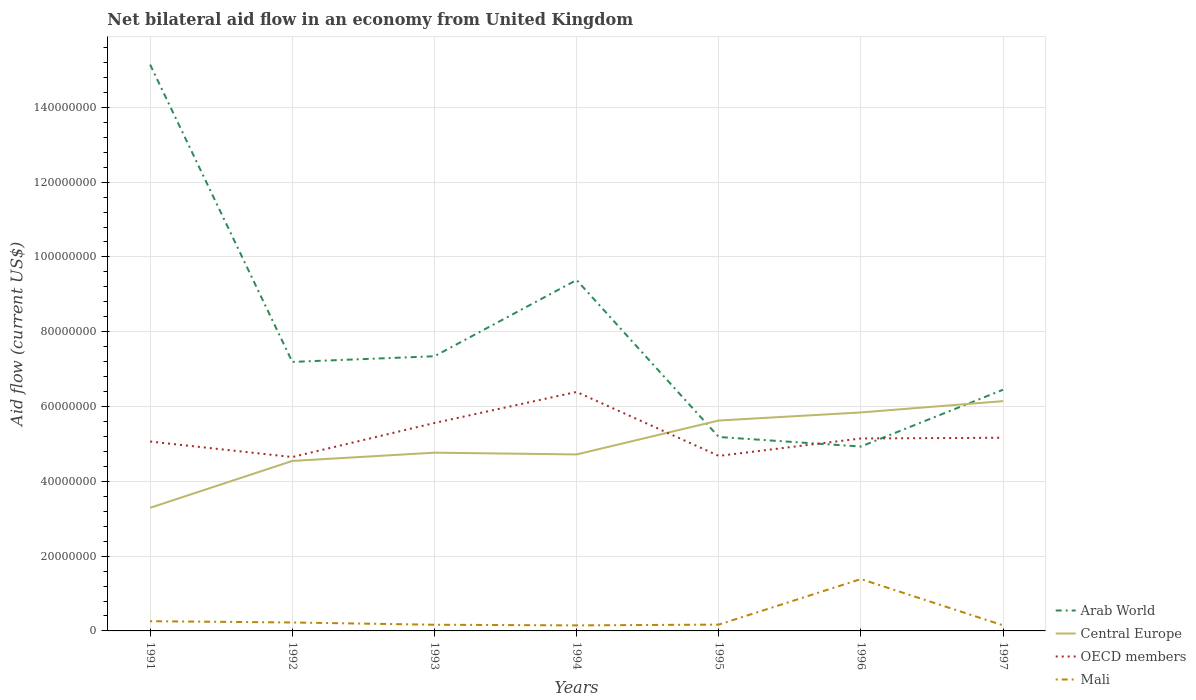Does the line corresponding to Arab World intersect with the line corresponding to OECD members?
Your answer should be very brief. Yes. Is the number of lines equal to the number of legend labels?
Ensure brevity in your answer.  Yes. Across all years, what is the maximum net bilateral aid flow in Arab World?
Your response must be concise. 4.93e+07. In which year was the net bilateral aid flow in Arab World maximum?
Provide a succinct answer. 1996. What is the total net bilateral aid flow in Central Europe in the graph?
Provide a short and direct response. -1.12e+07. What is the difference between the highest and the second highest net bilateral aid flow in Mali?
Your answer should be compact. 1.24e+07. What is the difference between the highest and the lowest net bilateral aid flow in OECD members?
Offer a very short reply. 2. Is the net bilateral aid flow in Mali strictly greater than the net bilateral aid flow in Arab World over the years?
Offer a very short reply. Yes. How many lines are there?
Your response must be concise. 4. How many years are there in the graph?
Give a very brief answer. 7. Where does the legend appear in the graph?
Provide a succinct answer. Bottom right. How many legend labels are there?
Your response must be concise. 4. How are the legend labels stacked?
Your response must be concise. Vertical. What is the title of the graph?
Keep it short and to the point. Net bilateral aid flow in an economy from United Kingdom. Does "Nigeria" appear as one of the legend labels in the graph?
Your answer should be very brief. No. What is the label or title of the X-axis?
Your answer should be compact. Years. What is the label or title of the Y-axis?
Provide a short and direct response. Aid flow (current US$). What is the Aid flow (current US$) of Arab World in 1991?
Offer a terse response. 1.51e+08. What is the Aid flow (current US$) in Central Europe in 1991?
Keep it short and to the point. 3.29e+07. What is the Aid flow (current US$) of OECD members in 1991?
Offer a very short reply. 5.06e+07. What is the Aid flow (current US$) of Mali in 1991?
Give a very brief answer. 2.60e+06. What is the Aid flow (current US$) of Arab World in 1992?
Keep it short and to the point. 7.19e+07. What is the Aid flow (current US$) in Central Europe in 1992?
Provide a short and direct response. 4.54e+07. What is the Aid flow (current US$) of OECD members in 1992?
Give a very brief answer. 4.65e+07. What is the Aid flow (current US$) of Mali in 1992?
Provide a short and direct response. 2.26e+06. What is the Aid flow (current US$) in Arab World in 1993?
Offer a very short reply. 7.34e+07. What is the Aid flow (current US$) of Central Europe in 1993?
Provide a short and direct response. 4.77e+07. What is the Aid flow (current US$) in OECD members in 1993?
Provide a short and direct response. 5.56e+07. What is the Aid flow (current US$) of Mali in 1993?
Offer a terse response. 1.65e+06. What is the Aid flow (current US$) of Arab World in 1994?
Keep it short and to the point. 9.38e+07. What is the Aid flow (current US$) in Central Europe in 1994?
Ensure brevity in your answer.  4.72e+07. What is the Aid flow (current US$) in OECD members in 1994?
Offer a terse response. 6.39e+07. What is the Aid flow (current US$) of Mali in 1994?
Offer a very short reply. 1.48e+06. What is the Aid flow (current US$) of Arab World in 1995?
Ensure brevity in your answer.  5.18e+07. What is the Aid flow (current US$) in Central Europe in 1995?
Your response must be concise. 5.63e+07. What is the Aid flow (current US$) in OECD members in 1995?
Offer a very short reply. 4.68e+07. What is the Aid flow (current US$) in Mali in 1995?
Your response must be concise. 1.69e+06. What is the Aid flow (current US$) of Arab World in 1996?
Keep it short and to the point. 4.93e+07. What is the Aid flow (current US$) in Central Europe in 1996?
Offer a terse response. 5.84e+07. What is the Aid flow (current US$) in OECD members in 1996?
Ensure brevity in your answer.  5.15e+07. What is the Aid flow (current US$) in Mali in 1996?
Provide a succinct answer. 1.39e+07. What is the Aid flow (current US$) of Arab World in 1997?
Offer a terse response. 6.45e+07. What is the Aid flow (current US$) of Central Europe in 1997?
Offer a very short reply. 6.14e+07. What is the Aid flow (current US$) of OECD members in 1997?
Offer a terse response. 5.16e+07. What is the Aid flow (current US$) of Mali in 1997?
Offer a very short reply. 1.49e+06. Across all years, what is the maximum Aid flow (current US$) of Arab World?
Offer a very short reply. 1.51e+08. Across all years, what is the maximum Aid flow (current US$) of Central Europe?
Your answer should be compact. 6.14e+07. Across all years, what is the maximum Aid flow (current US$) of OECD members?
Offer a terse response. 6.39e+07. Across all years, what is the maximum Aid flow (current US$) of Mali?
Offer a very short reply. 1.39e+07. Across all years, what is the minimum Aid flow (current US$) of Arab World?
Ensure brevity in your answer.  4.93e+07. Across all years, what is the minimum Aid flow (current US$) of Central Europe?
Offer a terse response. 3.29e+07. Across all years, what is the minimum Aid flow (current US$) in OECD members?
Offer a terse response. 4.65e+07. Across all years, what is the minimum Aid flow (current US$) in Mali?
Ensure brevity in your answer.  1.48e+06. What is the total Aid flow (current US$) of Arab World in the graph?
Provide a succinct answer. 5.56e+08. What is the total Aid flow (current US$) in Central Europe in the graph?
Make the answer very short. 3.49e+08. What is the total Aid flow (current US$) in OECD members in the graph?
Make the answer very short. 3.67e+08. What is the total Aid flow (current US$) of Mali in the graph?
Your response must be concise. 2.50e+07. What is the difference between the Aid flow (current US$) of Arab World in 1991 and that in 1992?
Provide a short and direct response. 7.95e+07. What is the difference between the Aid flow (current US$) of Central Europe in 1991 and that in 1992?
Keep it short and to the point. -1.25e+07. What is the difference between the Aid flow (current US$) of OECD members in 1991 and that in 1992?
Your answer should be very brief. 4.15e+06. What is the difference between the Aid flow (current US$) of Mali in 1991 and that in 1992?
Keep it short and to the point. 3.40e+05. What is the difference between the Aid flow (current US$) of Arab World in 1991 and that in 1993?
Your answer should be compact. 7.80e+07. What is the difference between the Aid flow (current US$) of Central Europe in 1991 and that in 1993?
Your answer should be compact. -1.47e+07. What is the difference between the Aid flow (current US$) of OECD members in 1991 and that in 1993?
Your response must be concise. -4.96e+06. What is the difference between the Aid flow (current US$) of Mali in 1991 and that in 1993?
Your response must be concise. 9.50e+05. What is the difference between the Aid flow (current US$) in Arab World in 1991 and that in 1994?
Provide a short and direct response. 5.76e+07. What is the difference between the Aid flow (current US$) in Central Europe in 1991 and that in 1994?
Your response must be concise. -1.43e+07. What is the difference between the Aid flow (current US$) of OECD members in 1991 and that in 1994?
Offer a terse response. -1.33e+07. What is the difference between the Aid flow (current US$) in Mali in 1991 and that in 1994?
Provide a short and direct response. 1.12e+06. What is the difference between the Aid flow (current US$) in Arab World in 1991 and that in 1995?
Make the answer very short. 9.96e+07. What is the difference between the Aid flow (current US$) of Central Europe in 1991 and that in 1995?
Offer a terse response. -2.33e+07. What is the difference between the Aid flow (current US$) of OECD members in 1991 and that in 1995?
Your answer should be very brief. 3.84e+06. What is the difference between the Aid flow (current US$) in Mali in 1991 and that in 1995?
Keep it short and to the point. 9.10e+05. What is the difference between the Aid flow (current US$) of Arab World in 1991 and that in 1996?
Ensure brevity in your answer.  1.02e+08. What is the difference between the Aid flow (current US$) in Central Europe in 1991 and that in 1996?
Give a very brief answer. -2.55e+07. What is the difference between the Aid flow (current US$) in OECD members in 1991 and that in 1996?
Keep it short and to the point. -8.20e+05. What is the difference between the Aid flow (current US$) of Mali in 1991 and that in 1996?
Keep it short and to the point. -1.13e+07. What is the difference between the Aid flow (current US$) in Arab World in 1991 and that in 1997?
Provide a short and direct response. 8.69e+07. What is the difference between the Aid flow (current US$) in Central Europe in 1991 and that in 1997?
Keep it short and to the point. -2.85e+07. What is the difference between the Aid flow (current US$) in OECD members in 1991 and that in 1997?
Provide a succinct answer. -1.01e+06. What is the difference between the Aid flow (current US$) in Mali in 1991 and that in 1997?
Your answer should be compact. 1.11e+06. What is the difference between the Aid flow (current US$) of Arab World in 1992 and that in 1993?
Provide a succinct answer. -1.51e+06. What is the difference between the Aid flow (current US$) of Central Europe in 1992 and that in 1993?
Provide a succinct answer. -2.21e+06. What is the difference between the Aid flow (current US$) in OECD members in 1992 and that in 1993?
Keep it short and to the point. -9.11e+06. What is the difference between the Aid flow (current US$) of Arab World in 1992 and that in 1994?
Offer a very short reply. -2.19e+07. What is the difference between the Aid flow (current US$) in Central Europe in 1992 and that in 1994?
Ensure brevity in your answer.  -1.74e+06. What is the difference between the Aid flow (current US$) of OECD members in 1992 and that in 1994?
Make the answer very short. -1.74e+07. What is the difference between the Aid flow (current US$) in Mali in 1992 and that in 1994?
Offer a very short reply. 7.80e+05. What is the difference between the Aid flow (current US$) of Arab World in 1992 and that in 1995?
Provide a short and direct response. 2.01e+07. What is the difference between the Aid flow (current US$) in Central Europe in 1992 and that in 1995?
Offer a terse response. -1.08e+07. What is the difference between the Aid flow (current US$) in OECD members in 1992 and that in 1995?
Your answer should be compact. -3.10e+05. What is the difference between the Aid flow (current US$) of Mali in 1992 and that in 1995?
Your response must be concise. 5.70e+05. What is the difference between the Aid flow (current US$) of Arab World in 1992 and that in 1996?
Ensure brevity in your answer.  2.26e+07. What is the difference between the Aid flow (current US$) in Central Europe in 1992 and that in 1996?
Ensure brevity in your answer.  -1.30e+07. What is the difference between the Aid flow (current US$) of OECD members in 1992 and that in 1996?
Your answer should be compact. -4.97e+06. What is the difference between the Aid flow (current US$) of Mali in 1992 and that in 1996?
Your answer should be compact. -1.16e+07. What is the difference between the Aid flow (current US$) in Arab World in 1992 and that in 1997?
Ensure brevity in your answer.  7.44e+06. What is the difference between the Aid flow (current US$) of Central Europe in 1992 and that in 1997?
Give a very brief answer. -1.60e+07. What is the difference between the Aid flow (current US$) of OECD members in 1992 and that in 1997?
Make the answer very short. -5.16e+06. What is the difference between the Aid flow (current US$) of Mali in 1992 and that in 1997?
Your response must be concise. 7.70e+05. What is the difference between the Aid flow (current US$) of Arab World in 1993 and that in 1994?
Provide a succinct answer. -2.04e+07. What is the difference between the Aid flow (current US$) of Central Europe in 1993 and that in 1994?
Offer a terse response. 4.70e+05. What is the difference between the Aid flow (current US$) in OECD members in 1993 and that in 1994?
Provide a succinct answer. -8.30e+06. What is the difference between the Aid flow (current US$) in Mali in 1993 and that in 1994?
Your answer should be very brief. 1.70e+05. What is the difference between the Aid flow (current US$) of Arab World in 1993 and that in 1995?
Keep it short and to the point. 2.16e+07. What is the difference between the Aid flow (current US$) of Central Europe in 1993 and that in 1995?
Provide a succinct answer. -8.60e+06. What is the difference between the Aid flow (current US$) in OECD members in 1993 and that in 1995?
Your answer should be very brief. 8.80e+06. What is the difference between the Aid flow (current US$) in Arab World in 1993 and that in 1996?
Make the answer very short. 2.41e+07. What is the difference between the Aid flow (current US$) in Central Europe in 1993 and that in 1996?
Your answer should be very brief. -1.08e+07. What is the difference between the Aid flow (current US$) in OECD members in 1993 and that in 1996?
Your answer should be compact. 4.14e+06. What is the difference between the Aid flow (current US$) of Mali in 1993 and that in 1996?
Your response must be concise. -1.22e+07. What is the difference between the Aid flow (current US$) in Arab World in 1993 and that in 1997?
Provide a short and direct response. 8.95e+06. What is the difference between the Aid flow (current US$) of Central Europe in 1993 and that in 1997?
Keep it short and to the point. -1.38e+07. What is the difference between the Aid flow (current US$) of OECD members in 1993 and that in 1997?
Keep it short and to the point. 3.95e+06. What is the difference between the Aid flow (current US$) of Arab World in 1994 and that in 1995?
Offer a very short reply. 4.20e+07. What is the difference between the Aid flow (current US$) of Central Europe in 1994 and that in 1995?
Keep it short and to the point. -9.07e+06. What is the difference between the Aid flow (current US$) in OECD members in 1994 and that in 1995?
Keep it short and to the point. 1.71e+07. What is the difference between the Aid flow (current US$) in Mali in 1994 and that in 1995?
Your response must be concise. -2.10e+05. What is the difference between the Aid flow (current US$) of Arab World in 1994 and that in 1996?
Provide a short and direct response. 4.45e+07. What is the difference between the Aid flow (current US$) in Central Europe in 1994 and that in 1996?
Your response must be concise. -1.12e+07. What is the difference between the Aid flow (current US$) of OECD members in 1994 and that in 1996?
Make the answer very short. 1.24e+07. What is the difference between the Aid flow (current US$) of Mali in 1994 and that in 1996?
Keep it short and to the point. -1.24e+07. What is the difference between the Aid flow (current US$) in Arab World in 1994 and that in 1997?
Keep it short and to the point. 2.93e+07. What is the difference between the Aid flow (current US$) in Central Europe in 1994 and that in 1997?
Your answer should be very brief. -1.42e+07. What is the difference between the Aid flow (current US$) of OECD members in 1994 and that in 1997?
Your response must be concise. 1.22e+07. What is the difference between the Aid flow (current US$) in Arab World in 1995 and that in 1996?
Make the answer very short. 2.55e+06. What is the difference between the Aid flow (current US$) of Central Europe in 1995 and that in 1996?
Your response must be concise. -2.16e+06. What is the difference between the Aid flow (current US$) in OECD members in 1995 and that in 1996?
Your answer should be very brief. -4.66e+06. What is the difference between the Aid flow (current US$) of Mali in 1995 and that in 1996?
Your answer should be compact. -1.22e+07. What is the difference between the Aid flow (current US$) in Arab World in 1995 and that in 1997?
Make the answer very short. -1.26e+07. What is the difference between the Aid flow (current US$) of Central Europe in 1995 and that in 1997?
Keep it short and to the point. -5.18e+06. What is the difference between the Aid flow (current US$) in OECD members in 1995 and that in 1997?
Make the answer very short. -4.85e+06. What is the difference between the Aid flow (current US$) of Arab World in 1996 and that in 1997?
Keep it short and to the point. -1.52e+07. What is the difference between the Aid flow (current US$) in Central Europe in 1996 and that in 1997?
Ensure brevity in your answer.  -3.02e+06. What is the difference between the Aid flow (current US$) in OECD members in 1996 and that in 1997?
Offer a very short reply. -1.90e+05. What is the difference between the Aid flow (current US$) of Mali in 1996 and that in 1997?
Your answer should be compact. 1.24e+07. What is the difference between the Aid flow (current US$) of Arab World in 1991 and the Aid flow (current US$) of Central Europe in 1992?
Your answer should be very brief. 1.06e+08. What is the difference between the Aid flow (current US$) in Arab World in 1991 and the Aid flow (current US$) in OECD members in 1992?
Offer a terse response. 1.05e+08. What is the difference between the Aid flow (current US$) in Arab World in 1991 and the Aid flow (current US$) in Mali in 1992?
Offer a terse response. 1.49e+08. What is the difference between the Aid flow (current US$) of Central Europe in 1991 and the Aid flow (current US$) of OECD members in 1992?
Give a very brief answer. -1.36e+07. What is the difference between the Aid flow (current US$) of Central Europe in 1991 and the Aid flow (current US$) of Mali in 1992?
Offer a terse response. 3.07e+07. What is the difference between the Aid flow (current US$) in OECD members in 1991 and the Aid flow (current US$) in Mali in 1992?
Make the answer very short. 4.84e+07. What is the difference between the Aid flow (current US$) in Arab World in 1991 and the Aid flow (current US$) in Central Europe in 1993?
Provide a short and direct response. 1.04e+08. What is the difference between the Aid flow (current US$) of Arab World in 1991 and the Aid flow (current US$) of OECD members in 1993?
Offer a terse response. 9.58e+07. What is the difference between the Aid flow (current US$) in Arab World in 1991 and the Aid flow (current US$) in Mali in 1993?
Ensure brevity in your answer.  1.50e+08. What is the difference between the Aid flow (current US$) in Central Europe in 1991 and the Aid flow (current US$) in OECD members in 1993?
Provide a succinct answer. -2.27e+07. What is the difference between the Aid flow (current US$) in Central Europe in 1991 and the Aid flow (current US$) in Mali in 1993?
Provide a succinct answer. 3.13e+07. What is the difference between the Aid flow (current US$) in OECD members in 1991 and the Aid flow (current US$) in Mali in 1993?
Provide a short and direct response. 4.90e+07. What is the difference between the Aid flow (current US$) in Arab World in 1991 and the Aid flow (current US$) in Central Europe in 1994?
Your answer should be compact. 1.04e+08. What is the difference between the Aid flow (current US$) in Arab World in 1991 and the Aid flow (current US$) in OECD members in 1994?
Ensure brevity in your answer.  8.75e+07. What is the difference between the Aid flow (current US$) in Arab World in 1991 and the Aid flow (current US$) in Mali in 1994?
Provide a succinct answer. 1.50e+08. What is the difference between the Aid flow (current US$) of Central Europe in 1991 and the Aid flow (current US$) of OECD members in 1994?
Offer a very short reply. -3.10e+07. What is the difference between the Aid flow (current US$) of Central Europe in 1991 and the Aid flow (current US$) of Mali in 1994?
Your answer should be very brief. 3.14e+07. What is the difference between the Aid flow (current US$) in OECD members in 1991 and the Aid flow (current US$) in Mali in 1994?
Provide a short and direct response. 4.92e+07. What is the difference between the Aid flow (current US$) in Arab World in 1991 and the Aid flow (current US$) in Central Europe in 1995?
Provide a succinct answer. 9.52e+07. What is the difference between the Aid flow (current US$) in Arab World in 1991 and the Aid flow (current US$) in OECD members in 1995?
Your response must be concise. 1.05e+08. What is the difference between the Aid flow (current US$) of Arab World in 1991 and the Aid flow (current US$) of Mali in 1995?
Give a very brief answer. 1.50e+08. What is the difference between the Aid flow (current US$) in Central Europe in 1991 and the Aid flow (current US$) in OECD members in 1995?
Your answer should be compact. -1.39e+07. What is the difference between the Aid flow (current US$) of Central Europe in 1991 and the Aid flow (current US$) of Mali in 1995?
Give a very brief answer. 3.12e+07. What is the difference between the Aid flow (current US$) in OECD members in 1991 and the Aid flow (current US$) in Mali in 1995?
Give a very brief answer. 4.90e+07. What is the difference between the Aid flow (current US$) of Arab World in 1991 and the Aid flow (current US$) of Central Europe in 1996?
Ensure brevity in your answer.  9.30e+07. What is the difference between the Aid flow (current US$) of Arab World in 1991 and the Aid flow (current US$) of OECD members in 1996?
Your answer should be compact. 1.00e+08. What is the difference between the Aid flow (current US$) of Arab World in 1991 and the Aid flow (current US$) of Mali in 1996?
Make the answer very short. 1.38e+08. What is the difference between the Aid flow (current US$) of Central Europe in 1991 and the Aid flow (current US$) of OECD members in 1996?
Keep it short and to the point. -1.85e+07. What is the difference between the Aid flow (current US$) of Central Europe in 1991 and the Aid flow (current US$) of Mali in 1996?
Your answer should be compact. 1.90e+07. What is the difference between the Aid flow (current US$) of OECD members in 1991 and the Aid flow (current US$) of Mali in 1996?
Provide a short and direct response. 3.68e+07. What is the difference between the Aid flow (current US$) in Arab World in 1991 and the Aid flow (current US$) in Central Europe in 1997?
Offer a terse response. 9.00e+07. What is the difference between the Aid flow (current US$) in Arab World in 1991 and the Aid flow (current US$) in OECD members in 1997?
Offer a very short reply. 9.98e+07. What is the difference between the Aid flow (current US$) in Arab World in 1991 and the Aid flow (current US$) in Mali in 1997?
Your answer should be compact. 1.50e+08. What is the difference between the Aid flow (current US$) of Central Europe in 1991 and the Aid flow (current US$) of OECD members in 1997?
Your answer should be compact. -1.87e+07. What is the difference between the Aid flow (current US$) in Central Europe in 1991 and the Aid flow (current US$) in Mali in 1997?
Provide a short and direct response. 3.14e+07. What is the difference between the Aid flow (current US$) in OECD members in 1991 and the Aid flow (current US$) in Mali in 1997?
Provide a succinct answer. 4.92e+07. What is the difference between the Aid flow (current US$) in Arab World in 1992 and the Aid flow (current US$) in Central Europe in 1993?
Your answer should be compact. 2.43e+07. What is the difference between the Aid flow (current US$) of Arab World in 1992 and the Aid flow (current US$) of OECD members in 1993?
Give a very brief answer. 1.63e+07. What is the difference between the Aid flow (current US$) in Arab World in 1992 and the Aid flow (current US$) in Mali in 1993?
Make the answer very short. 7.03e+07. What is the difference between the Aid flow (current US$) in Central Europe in 1992 and the Aid flow (current US$) in OECD members in 1993?
Offer a terse response. -1.02e+07. What is the difference between the Aid flow (current US$) in Central Europe in 1992 and the Aid flow (current US$) in Mali in 1993?
Make the answer very short. 4.38e+07. What is the difference between the Aid flow (current US$) of OECD members in 1992 and the Aid flow (current US$) of Mali in 1993?
Your answer should be compact. 4.48e+07. What is the difference between the Aid flow (current US$) in Arab World in 1992 and the Aid flow (current US$) in Central Europe in 1994?
Offer a terse response. 2.47e+07. What is the difference between the Aid flow (current US$) in Arab World in 1992 and the Aid flow (current US$) in OECD members in 1994?
Ensure brevity in your answer.  8.03e+06. What is the difference between the Aid flow (current US$) in Arab World in 1992 and the Aid flow (current US$) in Mali in 1994?
Your answer should be compact. 7.04e+07. What is the difference between the Aid flow (current US$) in Central Europe in 1992 and the Aid flow (current US$) in OECD members in 1994?
Keep it short and to the point. -1.84e+07. What is the difference between the Aid flow (current US$) of Central Europe in 1992 and the Aid flow (current US$) of Mali in 1994?
Your answer should be compact. 4.40e+07. What is the difference between the Aid flow (current US$) of OECD members in 1992 and the Aid flow (current US$) of Mali in 1994?
Make the answer very short. 4.50e+07. What is the difference between the Aid flow (current US$) of Arab World in 1992 and the Aid flow (current US$) of Central Europe in 1995?
Your answer should be compact. 1.57e+07. What is the difference between the Aid flow (current US$) of Arab World in 1992 and the Aid flow (current US$) of OECD members in 1995?
Offer a terse response. 2.51e+07. What is the difference between the Aid flow (current US$) in Arab World in 1992 and the Aid flow (current US$) in Mali in 1995?
Give a very brief answer. 7.02e+07. What is the difference between the Aid flow (current US$) of Central Europe in 1992 and the Aid flow (current US$) of OECD members in 1995?
Your answer should be very brief. -1.35e+06. What is the difference between the Aid flow (current US$) in Central Europe in 1992 and the Aid flow (current US$) in Mali in 1995?
Make the answer very short. 4.38e+07. What is the difference between the Aid flow (current US$) of OECD members in 1992 and the Aid flow (current US$) of Mali in 1995?
Provide a succinct answer. 4.48e+07. What is the difference between the Aid flow (current US$) in Arab World in 1992 and the Aid flow (current US$) in Central Europe in 1996?
Your answer should be very brief. 1.35e+07. What is the difference between the Aid flow (current US$) in Arab World in 1992 and the Aid flow (current US$) in OECD members in 1996?
Ensure brevity in your answer.  2.05e+07. What is the difference between the Aid flow (current US$) in Arab World in 1992 and the Aid flow (current US$) in Mali in 1996?
Provide a succinct answer. 5.81e+07. What is the difference between the Aid flow (current US$) in Central Europe in 1992 and the Aid flow (current US$) in OECD members in 1996?
Ensure brevity in your answer.  -6.01e+06. What is the difference between the Aid flow (current US$) of Central Europe in 1992 and the Aid flow (current US$) of Mali in 1996?
Your response must be concise. 3.16e+07. What is the difference between the Aid flow (current US$) of OECD members in 1992 and the Aid flow (current US$) of Mali in 1996?
Offer a very short reply. 3.26e+07. What is the difference between the Aid flow (current US$) of Arab World in 1992 and the Aid flow (current US$) of Central Europe in 1997?
Your answer should be very brief. 1.05e+07. What is the difference between the Aid flow (current US$) of Arab World in 1992 and the Aid flow (current US$) of OECD members in 1997?
Your answer should be very brief. 2.03e+07. What is the difference between the Aid flow (current US$) of Arab World in 1992 and the Aid flow (current US$) of Mali in 1997?
Offer a terse response. 7.04e+07. What is the difference between the Aid flow (current US$) of Central Europe in 1992 and the Aid flow (current US$) of OECD members in 1997?
Your response must be concise. -6.20e+06. What is the difference between the Aid flow (current US$) of Central Europe in 1992 and the Aid flow (current US$) of Mali in 1997?
Offer a very short reply. 4.40e+07. What is the difference between the Aid flow (current US$) in OECD members in 1992 and the Aid flow (current US$) in Mali in 1997?
Your answer should be compact. 4.50e+07. What is the difference between the Aid flow (current US$) in Arab World in 1993 and the Aid flow (current US$) in Central Europe in 1994?
Your response must be concise. 2.62e+07. What is the difference between the Aid flow (current US$) of Arab World in 1993 and the Aid flow (current US$) of OECD members in 1994?
Keep it short and to the point. 9.54e+06. What is the difference between the Aid flow (current US$) in Arab World in 1993 and the Aid flow (current US$) in Mali in 1994?
Keep it short and to the point. 7.20e+07. What is the difference between the Aid flow (current US$) in Central Europe in 1993 and the Aid flow (current US$) in OECD members in 1994?
Offer a very short reply. -1.62e+07. What is the difference between the Aid flow (current US$) in Central Europe in 1993 and the Aid flow (current US$) in Mali in 1994?
Your response must be concise. 4.62e+07. What is the difference between the Aid flow (current US$) in OECD members in 1993 and the Aid flow (current US$) in Mali in 1994?
Offer a very short reply. 5.41e+07. What is the difference between the Aid flow (current US$) in Arab World in 1993 and the Aid flow (current US$) in Central Europe in 1995?
Your answer should be compact. 1.72e+07. What is the difference between the Aid flow (current US$) of Arab World in 1993 and the Aid flow (current US$) of OECD members in 1995?
Provide a short and direct response. 2.66e+07. What is the difference between the Aid flow (current US$) of Arab World in 1993 and the Aid flow (current US$) of Mali in 1995?
Provide a short and direct response. 7.18e+07. What is the difference between the Aid flow (current US$) in Central Europe in 1993 and the Aid flow (current US$) in OECD members in 1995?
Offer a very short reply. 8.60e+05. What is the difference between the Aid flow (current US$) in Central Europe in 1993 and the Aid flow (current US$) in Mali in 1995?
Your response must be concise. 4.60e+07. What is the difference between the Aid flow (current US$) in OECD members in 1993 and the Aid flow (current US$) in Mali in 1995?
Offer a terse response. 5.39e+07. What is the difference between the Aid flow (current US$) in Arab World in 1993 and the Aid flow (current US$) in Central Europe in 1996?
Offer a very short reply. 1.50e+07. What is the difference between the Aid flow (current US$) of Arab World in 1993 and the Aid flow (current US$) of OECD members in 1996?
Ensure brevity in your answer.  2.20e+07. What is the difference between the Aid flow (current US$) in Arab World in 1993 and the Aid flow (current US$) in Mali in 1996?
Ensure brevity in your answer.  5.96e+07. What is the difference between the Aid flow (current US$) of Central Europe in 1993 and the Aid flow (current US$) of OECD members in 1996?
Ensure brevity in your answer.  -3.80e+06. What is the difference between the Aid flow (current US$) in Central Europe in 1993 and the Aid flow (current US$) in Mali in 1996?
Your response must be concise. 3.38e+07. What is the difference between the Aid flow (current US$) in OECD members in 1993 and the Aid flow (current US$) in Mali in 1996?
Offer a terse response. 4.17e+07. What is the difference between the Aid flow (current US$) in Arab World in 1993 and the Aid flow (current US$) in Central Europe in 1997?
Offer a very short reply. 1.20e+07. What is the difference between the Aid flow (current US$) of Arab World in 1993 and the Aid flow (current US$) of OECD members in 1997?
Give a very brief answer. 2.18e+07. What is the difference between the Aid flow (current US$) of Arab World in 1993 and the Aid flow (current US$) of Mali in 1997?
Ensure brevity in your answer.  7.20e+07. What is the difference between the Aid flow (current US$) of Central Europe in 1993 and the Aid flow (current US$) of OECD members in 1997?
Make the answer very short. -3.99e+06. What is the difference between the Aid flow (current US$) in Central Europe in 1993 and the Aid flow (current US$) in Mali in 1997?
Provide a succinct answer. 4.62e+07. What is the difference between the Aid flow (current US$) in OECD members in 1993 and the Aid flow (current US$) in Mali in 1997?
Ensure brevity in your answer.  5.41e+07. What is the difference between the Aid flow (current US$) of Arab World in 1994 and the Aid flow (current US$) of Central Europe in 1995?
Keep it short and to the point. 3.76e+07. What is the difference between the Aid flow (current US$) of Arab World in 1994 and the Aid flow (current US$) of OECD members in 1995?
Give a very brief answer. 4.70e+07. What is the difference between the Aid flow (current US$) of Arab World in 1994 and the Aid flow (current US$) of Mali in 1995?
Provide a short and direct response. 9.21e+07. What is the difference between the Aid flow (current US$) in Central Europe in 1994 and the Aid flow (current US$) in OECD members in 1995?
Provide a succinct answer. 3.90e+05. What is the difference between the Aid flow (current US$) in Central Europe in 1994 and the Aid flow (current US$) in Mali in 1995?
Offer a very short reply. 4.55e+07. What is the difference between the Aid flow (current US$) of OECD members in 1994 and the Aid flow (current US$) of Mali in 1995?
Provide a short and direct response. 6.22e+07. What is the difference between the Aid flow (current US$) in Arab World in 1994 and the Aid flow (current US$) in Central Europe in 1996?
Offer a very short reply. 3.54e+07. What is the difference between the Aid flow (current US$) in Arab World in 1994 and the Aid flow (current US$) in OECD members in 1996?
Provide a succinct answer. 4.24e+07. What is the difference between the Aid flow (current US$) in Arab World in 1994 and the Aid flow (current US$) in Mali in 1996?
Keep it short and to the point. 8.00e+07. What is the difference between the Aid flow (current US$) of Central Europe in 1994 and the Aid flow (current US$) of OECD members in 1996?
Give a very brief answer. -4.27e+06. What is the difference between the Aid flow (current US$) of Central Europe in 1994 and the Aid flow (current US$) of Mali in 1996?
Offer a very short reply. 3.33e+07. What is the difference between the Aid flow (current US$) of OECD members in 1994 and the Aid flow (current US$) of Mali in 1996?
Your answer should be very brief. 5.00e+07. What is the difference between the Aid flow (current US$) of Arab World in 1994 and the Aid flow (current US$) of Central Europe in 1997?
Provide a succinct answer. 3.24e+07. What is the difference between the Aid flow (current US$) in Arab World in 1994 and the Aid flow (current US$) in OECD members in 1997?
Give a very brief answer. 4.22e+07. What is the difference between the Aid flow (current US$) of Arab World in 1994 and the Aid flow (current US$) of Mali in 1997?
Give a very brief answer. 9.23e+07. What is the difference between the Aid flow (current US$) in Central Europe in 1994 and the Aid flow (current US$) in OECD members in 1997?
Provide a short and direct response. -4.46e+06. What is the difference between the Aid flow (current US$) of Central Europe in 1994 and the Aid flow (current US$) of Mali in 1997?
Offer a terse response. 4.57e+07. What is the difference between the Aid flow (current US$) of OECD members in 1994 and the Aid flow (current US$) of Mali in 1997?
Provide a succinct answer. 6.24e+07. What is the difference between the Aid flow (current US$) of Arab World in 1995 and the Aid flow (current US$) of Central Europe in 1996?
Offer a very short reply. -6.57e+06. What is the difference between the Aid flow (current US$) of Arab World in 1995 and the Aid flow (current US$) of Mali in 1996?
Ensure brevity in your answer.  3.80e+07. What is the difference between the Aid flow (current US$) in Central Europe in 1995 and the Aid flow (current US$) in OECD members in 1996?
Your answer should be compact. 4.80e+06. What is the difference between the Aid flow (current US$) in Central Europe in 1995 and the Aid flow (current US$) in Mali in 1996?
Give a very brief answer. 4.24e+07. What is the difference between the Aid flow (current US$) of OECD members in 1995 and the Aid flow (current US$) of Mali in 1996?
Keep it short and to the point. 3.29e+07. What is the difference between the Aid flow (current US$) of Arab World in 1995 and the Aid flow (current US$) of Central Europe in 1997?
Your answer should be compact. -9.59e+06. What is the difference between the Aid flow (current US$) in Arab World in 1995 and the Aid flow (current US$) in OECD members in 1997?
Your answer should be very brief. 2.00e+05. What is the difference between the Aid flow (current US$) in Arab World in 1995 and the Aid flow (current US$) in Mali in 1997?
Offer a terse response. 5.04e+07. What is the difference between the Aid flow (current US$) in Central Europe in 1995 and the Aid flow (current US$) in OECD members in 1997?
Provide a short and direct response. 4.61e+06. What is the difference between the Aid flow (current US$) in Central Europe in 1995 and the Aid flow (current US$) in Mali in 1997?
Offer a very short reply. 5.48e+07. What is the difference between the Aid flow (current US$) of OECD members in 1995 and the Aid flow (current US$) of Mali in 1997?
Make the answer very short. 4.53e+07. What is the difference between the Aid flow (current US$) of Arab World in 1996 and the Aid flow (current US$) of Central Europe in 1997?
Your response must be concise. -1.21e+07. What is the difference between the Aid flow (current US$) in Arab World in 1996 and the Aid flow (current US$) in OECD members in 1997?
Provide a short and direct response. -2.35e+06. What is the difference between the Aid flow (current US$) of Arab World in 1996 and the Aid flow (current US$) of Mali in 1997?
Your answer should be compact. 4.78e+07. What is the difference between the Aid flow (current US$) in Central Europe in 1996 and the Aid flow (current US$) in OECD members in 1997?
Your answer should be compact. 6.77e+06. What is the difference between the Aid flow (current US$) in Central Europe in 1996 and the Aid flow (current US$) in Mali in 1997?
Provide a short and direct response. 5.69e+07. What is the difference between the Aid flow (current US$) of OECD members in 1996 and the Aid flow (current US$) of Mali in 1997?
Your answer should be very brief. 5.00e+07. What is the average Aid flow (current US$) of Arab World per year?
Offer a very short reply. 7.95e+07. What is the average Aid flow (current US$) of Central Europe per year?
Your answer should be very brief. 4.99e+07. What is the average Aid flow (current US$) of OECD members per year?
Your response must be concise. 5.24e+07. What is the average Aid flow (current US$) in Mali per year?
Your response must be concise. 3.58e+06. In the year 1991, what is the difference between the Aid flow (current US$) in Arab World and Aid flow (current US$) in Central Europe?
Provide a succinct answer. 1.18e+08. In the year 1991, what is the difference between the Aid flow (current US$) of Arab World and Aid flow (current US$) of OECD members?
Provide a succinct answer. 1.01e+08. In the year 1991, what is the difference between the Aid flow (current US$) in Arab World and Aid flow (current US$) in Mali?
Provide a short and direct response. 1.49e+08. In the year 1991, what is the difference between the Aid flow (current US$) in Central Europe and Aid flow (current US$) in OECD members?
Your answer should be very brief. -1.77e+07. In the year 1991, what is the difference between the Aid flow (current US$) of Central Europe and Aid flow (current US$) of Mali?
Offer a very short reply. 3.03e+07. In the year 1991, what is the difference between the Aid flow (current US$) in OECD members and Aid flow (current US$) in Mali?
Your answer should be compact. 4.80e+07. In the year 1992, what is the difference between the Aid flow (current US$) of Arab World and Aid flow (current US$) of Central Europe?
Your answer should be compact. 2.65e+07. In the year 1992, what is the difference between the Aid flow (current US$) in Arab World and Aid flow (current US$) in OECD members?
Your answer should be compact. 2.54e+07. In the year 1992, what is the difference between the Aid flow (current US$) in Arab World and Aid flow (current US$) in Mali?
Your answer should be compact. 6.97e+07. In the year 1992, what is the difference between the Aid flow (current US$) of Central Europe and Aid flow (current US$) of OECD members?
Make the answer very short. -1.04e+06. In the year 1992, what is the difference between the Aid flow (current US$) of Central Europe and Aid flow (current US$) of Mali?
Offer a terse response. 4.32e+07. In the year 1992, what is the difference between the Aid flow (current US$) in OECD members and Aid flow (current US$) in Mali?
Offer a very short reply. 4.42e+07. In the year 1993, what is the difference between the Aid flow (current US$) in Arab World and Aid flow (current US$) in Central Europe?
Keep it short and to the point. 2.58e+07. In the year 1993, what is the difference between the Aid flow (current US$) of Arab World and Aid flow (current US$) of OECD members?
Your answer should be very brief. 1.78e+07. In the year 1993, what is the difference between the Aid flow (current US$) in Arab World and Aid flow (current US$) in Mali?
Provide a succinct answer. 7.18e+07. In the year 1993, what is the difference between the Aid flow (current US$) in Central Europe and Aid flow (current US$) in OECD members?
Offer a very short reply. -7.94e+06. In the year 1993, what is the difference between the Aid flow (current US$) in Central Europe and Aid flow (current US$) in Mali?
Make the answer very short. 4.60e+07. In the year 1993, what is the difference between the Aid flow (current US$) of OECD members and Aid flow (current US$) of Mali?
Keep it short and to the point. 5.40e+07. In the year 1994, what is the difference between the Aid flow (current US$) of Arab World and Aid flow (current US$) of Central Europe?
Ensure brevity in your answer.  4.66e+07. In the year 1994, what is the difference between the Aid flow (current US$) of Arab World and Aid flow (current US$) of OECD members?
Make the answer very short. 2.99e+07. In the year 1994, what is the difference between the Aid flow (current US$) in Arab World and Aid flow (current US$) in Mali?
Provide a short and direct response. 9.24e+07. In the year 1994, what is the difference between the Aid flow (current US$) of Central Europe and Aid flow (current US$) of OECD members?
Offer a very short reply. -1.67e+07. In the year 1994, what is the difference between the Aid flow (current US$) of Central Europe and Aid flow (current US$) of Mali?
Make the answer very short. 4.57e+07. In the year 1994, what is the difference between the Aid flow (current US$) of OECD members and Aid flow (current US$) of Mali?
Ensure brevity in your answer.  6.24e+07. In the year 1995, what is the difference between the Aid flow (current US$) in Arab World and Aid flow (current US$) in Central Europe?
Your response must be concise. -4.41e+06. In the year 1995, what is the difference between the Aid flow (current US$) of Arab World and Aid flow (current US$) of OECD members?
Make the answer very short. 5.05e+06. In the year 1995, what is the difference between the Aid flow (current US$) in Arab World and Aid flow (current US$) in Mali?
Provide a short and direct response. 5.02e+07. In the year 1995, what is the difference between the Aid flow (current US$) of Central Europe and Aid flow (current US$) of OECD members?
Provide a succinct answer. 9.46e+06. In the year 1995, what is the difference between the Aid flow (current US$) of Central Europe and Aid flow (current US$) of Mali?
Offer a very short reply. 5.46e+07. In the year 1995, what is the difference between the Aid flow (current US$) of OECD members and Aid flow (current US$) of Mali?
Give a very brief answer. 4.51e+07. In the year 1996, what is the difference between the Aid flow (current US$) of Arab World and Aid flow (current US$) of Central Europe?
Your answer should be very brief. -9.12e+06. In the year 1996, what is the difference between the Aid flow (current US$) in Arab World and Aid flow (current US$) in OECD members?
Your answer should be very brief. -2.16e+06. In the year 1996, what is the difference between the Aid flow (current US$) of Arab World and Aid flow (current US$) of Mali?
Your answer should be very brief. 3.54e+07. In the year 1996, what is the difference between the Aid flow (current US$) of Central Europe and Aid flow (current US$) of OECD members?
Give a very brief answer. 6.96e+06. In the year 1996, what is the difference between the Aid flow (current US$) of Central Europe and Aid flow (current US$) of Mali?
Offer a terse response. 4.46e+07. In the year 1996, what is the difference between the Aid flow (current US$) of OECD members and Aid flow (current US$) of Mali?
Your response must be concise. 3.76e+07. In the year 1997, what is the difference between the Aid flow (current US$) in Arab World and Aid flow (current US$) in Central Europe?
Make the answer very short. 3.05e+06. In the year 1997, what is the difference between the Aid flow (current US$) in Arab World and Aid flow (current US$) in OECD members?
Your answer should be very brief. 1.28e+07. In the year 1997, what is the difference between the Aid flow (current US$) of Arab World and Aid flow (current US$) of Mali?
Provide a short and direct response. 6.30e+07. In the year 1997, what is the difference between the Aid flow (current US$) of Central Europe and Aid flow (current US$) of OECD members?
Keep it short and to the point. 9.79e+06. In the year 1997, what is the difference between the Aid flow (current US$) in Central Europe and Aid flow (current US$) in Mali?
Your response must be concise. 6.00e+07. In the year 1997, what is the difference between the Aid flow (current US$) in OECD members and Aid flow (current US$) in Mali?
Give a very brief answer. 5.02e+07. What is the ratio of the Aid flow (current US$) in Arab World in 1991 to that in 1992?
Your answer should be compact. 2.11. What is the ratio of the Aid flow (current US$) of Central Europe in 1991 to that in 1992?
Your answer should be very brief. 0.72. What is the ratio of the Aid flow (current US$) of OECD members in 1991 to that in 1992?
Give a very brief answer. 1.09. What is the ratio of the Aid flow (current US$) of Mali in 1991 to that in 1992?
Make the answer very short. 1.15. What is the ratio of the Aid flow (current US$) in Arab World in 1991 to that in 1993?
Give a very brief answer. 2.06. What is the ratio of the Aid flow (current US$) in Central Europe in 1991 to that in 1993?
Ensure brevity in your answer.  0.69. What is the ratio of the Aid flow (current US$) in OECD members in 1991 to that in 1993?
Give a very brief answer. 0.91. What is the ratio of the Aid flow (current US$) of Mali in 1991 to that in 1993?
Give a very brief answer. 1.58. What is the ratio of the Aid flow (current US$) of Arab World in 1991 to that in 1994?
Provide a succinct answer. 1.61. What is the ratio of the Aid flow (current US$) in Central Europe in 1991 to that in 1994?
Make the answer very short. 0.7. What is the ratio of the Aid flow (current US$) of OECD members in 1991 to that in 1994?
Keep it short and to the point. 0.79. What is the ratio of the Aid flow (current US$) of Mali in 1991 to that in 1994?
Offer a very short reply. 1.76. What is the ratio of the Aid flow (current US$) in Arab World in 1991 to that in 1995?
Your response must be concise. 2.92. What is the ratio of the Aid flow (current US$) in Central Europe in 1991 to that in 1995?
Your answer should be very brief. 0.59. What is the ratio of the Aid flow (current US$) in OECD members in 1991 to that in 1995?
Give a very brief answer. 1.08. What is the ratio of the Aid flow (current US$) of Mali in 1991 to that in 1995?
Your answer should be compact. 1.54. What is the ratio of the Aid flow (current US$) of Arab World in 1991 to that in 1996?
Your answer should be very brief. 3.07. What is the ratio of the Aid flow (current US$) of Central Europe in 1991 to that in 1996?
Make the answer very short. 0.56. What is the ratio of the Aid flow (current US$) in OECD members in 1991 to that in 1996?
Provide a succinct answer. 0.98. What is the ratio of the Aid flow (current US$) in Mali in 1991 to that in 1996?
Your response must be concise. 0.19. What is the ratio of the Aid flow (current US$) in Arab World in 1991 to that in 1997?
Provide a short and direct response. 2.35. What is the ratio of the Aid flow (current US$) in Central Europe in 1991 to that in 1997?
Make the answer very short. 0.54. What is the ratio of the Aid flow (current US$) in OECD members in 1991 to that in 1997?
Give a very brief answer. 0.98. What is the ratio of the Aid flow (current US$) of Mali in 1991 to that in 1997?
Your answer should be compact. 1.75. What is the ratio of the Aid flow (current US$) of Arab World in 1992 to that in 1993?
Keep it short and to the point. 0.98. What is the ratio of the Aid flow (current US$) in Central Europe in 1992 to that in 1993?
Your answer should be compact. 0.95. What is the ratio of the Aid flow (current US$) in OECD members in 1992 to that in 1993?
Offer a terse response. 0.84. What is the ratio of the Aid flow (current US$) in Mali in 1992 to that in 1993?
Offer a terse response. 1.37. What is the ratio of the Aid flow (current US$) in Arab World in 1992 to that in 1994?
Your response must be concise. 0.77. What is the ratio of the Aid flow (current US$) in Central Europe in 1992 to that in 1994?
Provide a short and direct response. 0.96. What is the ratio of the Aid flow (current US$) in OECD members in 1992 to that in 1994?
Make the answer very short. 0.73. What is the ratio of the Aid flow (current US$) of Mali in 1992 to that in 1994?
Give a very brief answer. 1.53. What is the ratio of the Aid flow (current US$) of Arab World in 1992 to that in 1995?
Give a very brief answer. 1.39. What is the ratio of the Aid flow (current US$) in Central Europe in 1992 to that in 1995?
Give a very brief answer. 0.81. What is the ratio of the Aid flow (current US$) in Mali in 1992 to that in 1995?
Offer a very short reply. 1.34. What is the ratio of the Aid flow (current US$) of Arab World in 1992 to that in 1996?
Your answer should be very brief. 1.46. What is the ratio of the Aid flow (current US$) of Central Europe in 1992 to that in 1996?
Provide a succinct answer. 0.78. What is the ratio of the Aid flow (current US$) in OECD members in 1992 to that in 1996?
Offer a very short reply. 0.9. What is the ratio of the Aid flow (current US$) in Mali in 1992 to that in 1996?
Make the answer very short. 0.16. What is the ratio of the Aid flow (current US$) of Arab World in 1992 to that in 1997?
Offer a very short reply. 1.12. What is the ratio of the Aid flow (current US$) of Central Europe in 1992 to that in 1997?
Make the answer very short. 0.74. What is the ratio of the Aid flow (current US$) of OECD members in 1992 to that in 1997?
Give a very brief answer. 0.9. What is the ratio of the Aid flow (current US$) in Mali in 1992 to that in 1997?
Ensure brevity in your answer.  1.52. What is the ratio of the Aid flow (current US$) of Arab World in 1993 to that in 1994?
Give a very brief answer. 0.78. What is the ratio of the Aid flow (current US$) of OECD members in 1993 to that in 1994?
Offer a terse response. 0.87. What is the ratio of the Aid flow (current US$) in Mali in 1993 to that in 1994?
Keep it short and to the point. 1.11. What is the ratio of the Aid flow (current US$) of Arab World in 1993 to that in 1995?
Keep it short and to the point. 1.42. What is the ratio of the Aid flow (current US$) in Central Europe in 1993 to that in 1995?
Make the answer very short. 0.85. What is the ratio of the Aid flow (current US$) in OECD members in 1993 to that in 1995?
Offer a terse response. 1.19. What is the ratio of the Aid flow (current US$) in Mali in 1993 to that in 1995?
Your response must be concise. 0.98. What is the ratio of the Aid flow (current US$) of Arab World in 1993 to that in 1996?
Your answer should be compact. 1.49. What is the ratio of the Aid flow (current US$) of Central Europe in 1993 to that in 1996?
Your answer should be very brief. 0.82. What is the ratio of the Aid flow (current US$) in OECD members in 1993 to that in 1996?
Your answer should be very brief. 1.08. What is the ratio of the Aid flow (current US$) of Mali in 1993 to that in 1996?
Your answer should be very brief. 0.12. What is the ratio of the Aid flow (current US$) in Arab World in 1993 to that in 1997?
Offer a terse response. 1.14. What is the ratio of the Aid flow (current US$) in Central Europe in 1993 to that in 1997?
Provide a succinct answer. 0.78. What is the ratio of the Aid flow (current US$) in OECD members in 1993 to that in 1997?
Your answer should be compact. 1.08. What is the ratio of the Aid flow (current US$) of Mali in 1993 to that in 1997?
Give a very brief answer. 1.11. What is the ratio of the Aid flow (current US$) in Arab World in 1994 to that in 1995?
Your response must be concise. 1.81. What is the ratio of the Aid flow (current US$) of Central Europe in 1994 to that in 1995?
Provide a succinct answer. 0.84. What is the ratio of the Aid flow (current US$) in OECD members in 1994 to that in 1995?
Your answer should be compact. 1.37. What is the ratio of the Aid flow (current US$) of Mali in 1994 to that in 1995?
Ensure brevity in your answer.  0.88. What is the ratio of the Aid flow (current US$) in Arab World in 1994 to that in 1996?
Ensure brevity in your answer.  1.9. What is the ratio of the Aid flow (current US$) in Central Europe in 1994 to that in 1996?
Your answer should be compact. 0.81. What is the ratio of the Aid flow (current US$) of OECD members in 1994 to that in 1996?
Offer a terse response. 1.24. What is the ratio of the Aid flow (current US$) in Mali in 1994 to that in 1996?
Make the answer very short. 0.11. What is the ratio of the Aid flow (current US$) in Arab World in 1994 to that in 1997?
Your answer should be very brief. 1.46. What is the ratio of the Aid flow (current US$) of Central Europe in 1994 to that in 1997?
Keep it short and to the point. 0.77. What is the ratio of the Aid flow (current US$) of OECD members in 1994 to that in 1997?
Offer a terse response. 1.24. What is the ratio of the Aid flow (current US$) of Mali in 1994 to that in 1997?
Ensure brevity in your answer.  0.99. What is the ratio of the Aid flow (current US$) in Arab World in 1995 to that in 1996?
Provide a short and direct response. 1.05. What is the ratio of the Aid flow (current US$) of OECD members in 1995 to that in 1996?
Ensure brevity in your answer.  0.91. What is the ratio of the Aid flow (current US$) of Mali in 1995 to that in 1996?
Your answer should be compact. 0.12. What is the ratio of the Aid flow (current US$) of Arab World in 1995 to that in 1997?
Make the answer very short. 0.8. What is the ratio of the Aid flow (current US$) of Central Europe in 1995 to that in 1997?
Provide a succinct answer. 0.92. What is the ratio of the Aid flow (current US$) of OECD members in 1995 to that in 1997?
Your answer should be compact. 0.91. What is the ratio of the Aid flow (current US$) of Mali in 1995 to that in 1997?
Offer a terse response. 1.13. What is the ratio of the Aid flow (current US$) in Arab World in 1996 to that in 1997?
Keep it short and to the point. 0.76. What is the ratio of the Aid flow (current US$) in Central Europe in 1996 to that in 1997?
Provide a succinct answer. 0.95. What is the ratio of the Aid flow (current US$) in OECD members in 1996 to that in 1997?
Offer a terse response. 1. What is the ratio of the Aid flow (current US$) of Mali in 1996 to that in 1997?
Offer a terse response. 9.31. What is the difference between the highest and the second highest Aid flow (current US$) of Arab World?
Make the answer very short. 5.76e+07. What is the difference between the highest and the second highest Aid flow (current US$) in Central Europe?
Give a very brief answer. 3.02e+06. What is the difference between the highest and the second highest Aid flow (current US$) of OECD members?
Give a very brief answer. 8.30e+06. What is the difference between the highest and the second highest Aid flow (current US$) of Mali?
Make the answer very short. 1.13e+07. What is the difference between the highest and the lowest Aid flow (current US$) in Arab World?
Provide a short and direct response. 1.02e+08. What is the difference between the highest and the lowest Aid flow (current US$) in Central Europe?
Keep it short and to the point. 2.85e+07. What is the difference between the highest and the lowest Aid flow (current US$) in OECD members?
Offer a terse response. 1.74e+07. What is the difference between the highest and the lowest Aid flow (current US$) of Mali?
Your answer should be compact. 1.24e+07. 